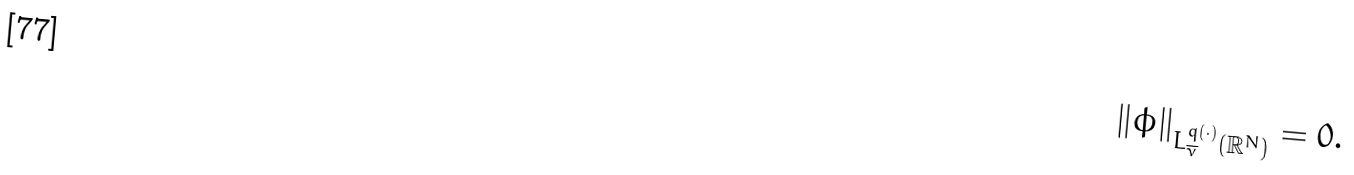Convert formula to latex. <formula><loc_0><loc_0><loc_500><loc_500>\| \phi \| _ { L ^ { q ( \cdot ) } _ { \overline { \nu } } ( \mathbb { R } ^ { N } ) } = 0 .</formula> 